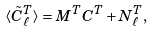<formula> <loc_0><loc_0><loc_500><loc_500>\langle \tilde { C } ^ { T } _ { \ell } \rangle = M ^ { T } C ^ { T } + N ^ { T } _ { \ell } ,</formula> 